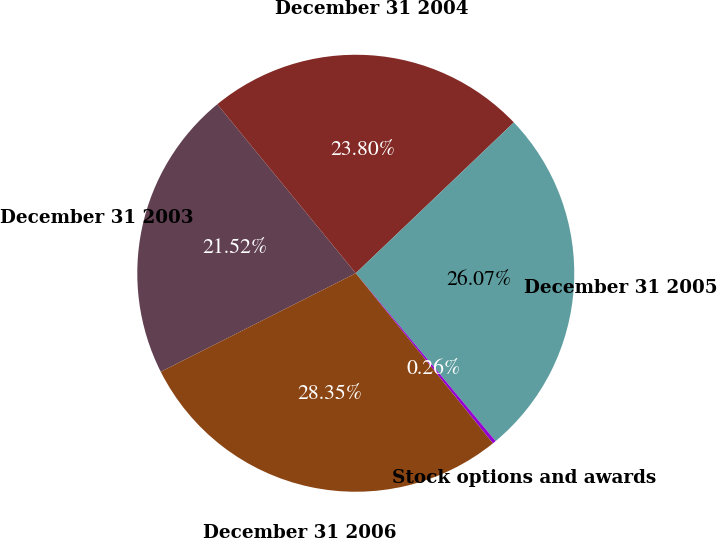<chart> <loc_0><loc_0><loc_500><loc_500><pie_chart><fcel>December 31 2003<fcel>December 31 2004<fcel>December 31 2005<fcel>Stock options and awards<fcel>December 31 2006<nl><fcel>21.52%<fcel>23.8%<fcel>26.07%<fcel>0.26%<fcel>28.35%<nl></chart> 